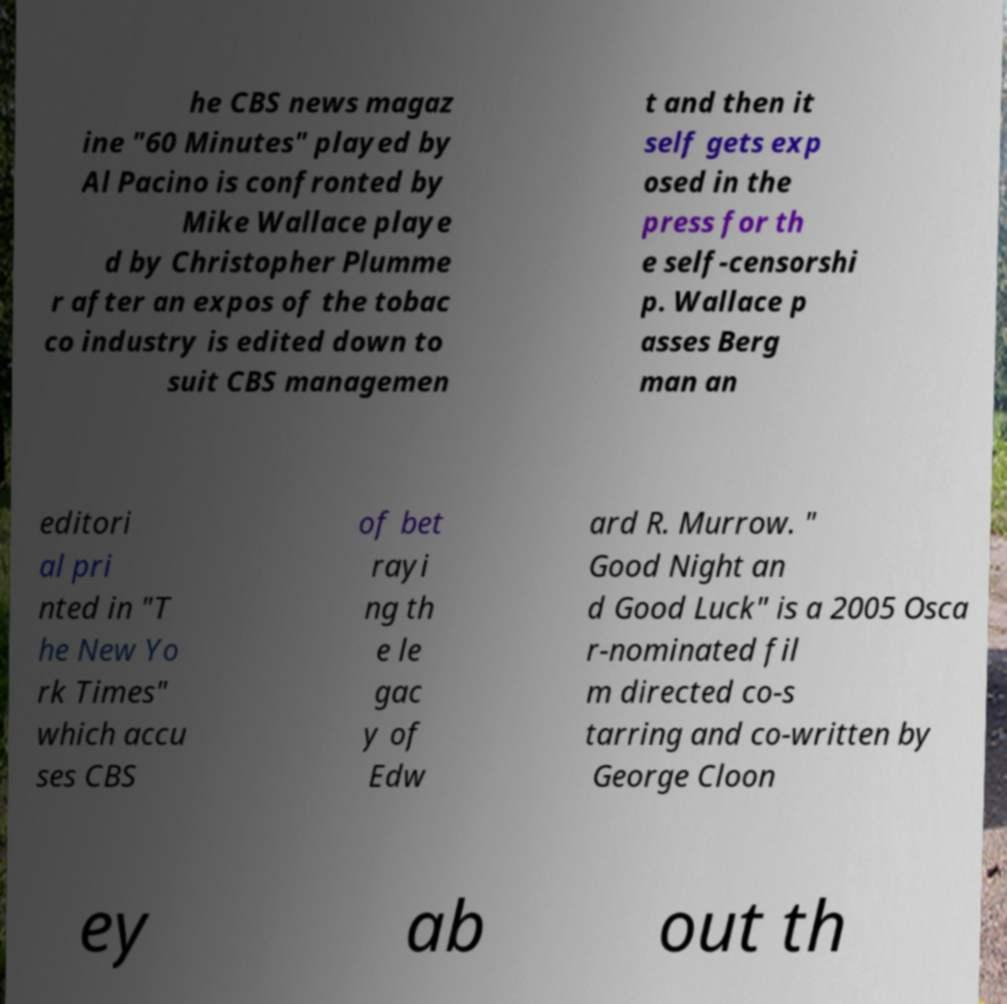For documentation purposes, I need the text within this image transcribed. Could you provide that? he CBS news magaz ine "60 Minutes" played by Al Pacino is confronted by Mike Wallace playe d by Christopher Plumme r after an expos of the tobac co industry is edited down to suit CBS managemen t and then it self gets exp osed in the press for th e self-censorshi p. Wallace p asses Berg man an editori al pri nted in "T he New Yo rk Times" which accu ses CBS of bet rayi ng th e le gac y of Edw ard R. Murrow. " Good Night an d Good Luck" is a 2005 Osca r-nominated fil m directed co-s tarring and co-written by George Cloon ey ab out th 